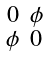Convert formula to latex. <formula><loc_0><loc_0><loc_500><loc_500>\begin{smallmatrix} 0 & \phi \\ \phi & 0 \end{smallmatrix}</formula> 